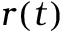<formula> <loc_0><loc_0><loc_500><loc_500>r ( t )</formula> 